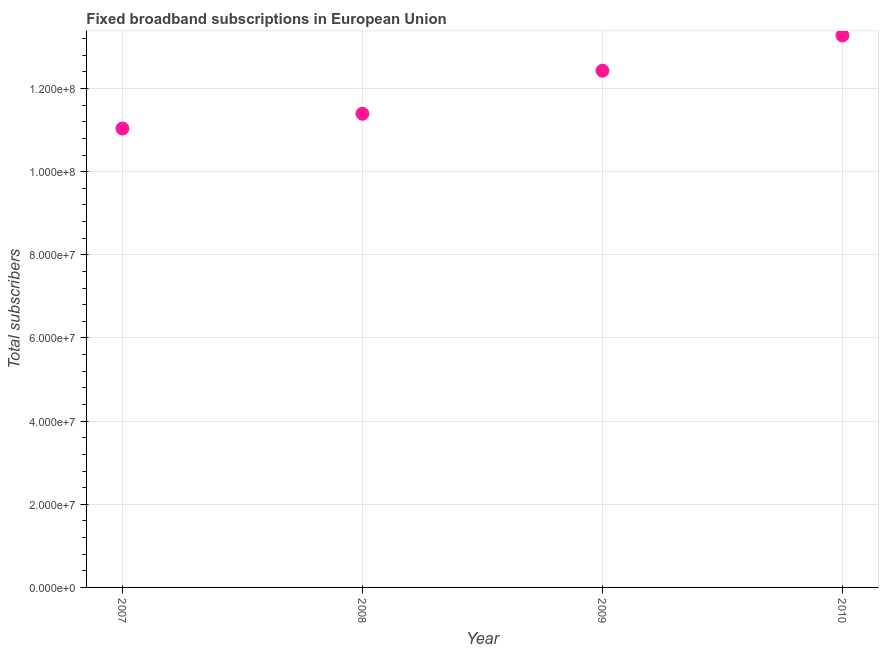What is the total number of fixed broadband subscriptions in 2009?
Offer a very short reply. 1.24e+08. Across all years, what is the maximum total number of fixed broadband subscriptions?
Your response must be concise. 1.33e+08. Across all years, what is the minimum total number of fixed broadband subscriptions?
Keep it short and to the point. 1.10e+08. In which year was the total number of fixed broadband subscriptions maximum?
Your response must be concise. 2010. In which year was the total number of fixed broadband subscriptions minimum?
Offer a terse response. 2007. What is the sum of the total number of fixed broadband subscriptions?
Provide a succinct answer. 4.81e+08. What is the difference between the total number of fixed broadband subscriptions in 2008 and 2010?
Give a very brief answer. -1.88e+07. What is the average total number of fixed broadband subscriptions per year?
Keep it short and to the point. 1.20e+08. What is the median total number of fixed broadband subscriptions?
Your answer should be very brief. 1.19e+08. In how many years, is the total number of fixed broadband subscriptions greater than 76000000 ?
Keep it short and to the point. 4. What is the ratio of the total number of fixed broadband subscriptions in 2007 to that in 2009?
Make the answer very short. 0.89. What is the difference between the highest and the second highest total number of fixed broadband subscriptions?
Keep it short and to the point. 8.48e+06. What is the difference between the highest and the lowest total number of fixed broadband subscriptions?
Your response must be concise. 2.24e+07. Does the graph contain any zero values?
Your response must be concise. No. Does the graph contain grids?
Provide a succinct answer. Yes. What is the title of the graph?
Your response must be concise. Fixed broadband subscriptions in European Union. What is the label or title of the Y-axis?
Ensure brevity in your answer.  Total subscribers. What is the Total subscribers in 2007?
Ensure brevity in your answer.  1.10e+08. What is the Total subscribers in 2008?
Offer a very short reply. 1.14e+08. What is the Total subscribers in 2009?
Keep it short and to the point. 1.24e+08. What is the Total subscribers in 2010?
Your answer should be very brief. 1.33e+08. What is the difference between the Total subscribers in 2007 and 2008?
Offer a terse response. -3.55e+06. What is the difference between the Total subscribers in 2007 and 2009?
Make the answer very short. -1.39e+07. What is the difference between the Total subscribers in 2007 and 2010?
Your response must be concise. -2.24e+07. What is the difference between the Total subscribers in 2008 and 2009?
Offer a very short reply. -1.04e+07. What is the difference between the Total subscribers in 2008 and 2010?
Your answer should be very brief. -1.88e+07. What is the difference between the Total subscribers in 2009 and 2010?
Offer a very short reply. -8.48e+06. What is the ratio of the Total subscribers in 2007 to that in 2008?
Make the answer very short. 0.97. What is the ratio of the Total subscribers in 2007 to that in 2009?
Your response must be concise. 0.89. What is the ratio of the Total subscribers in 2007 to that in 2010?
Your response must be concise. 0.83. What is the ratio of the Total subscribers in 2008 to that in 2009?
Make the answer very short. 0.92. What is the ratio of the Total subscribers in 2008 to that in 2010?
Offer a terse response. 0.86. What is the ratio of the Total subscribers in 2009 to that in 2010?
Provide a short and direct response. 0.94. 